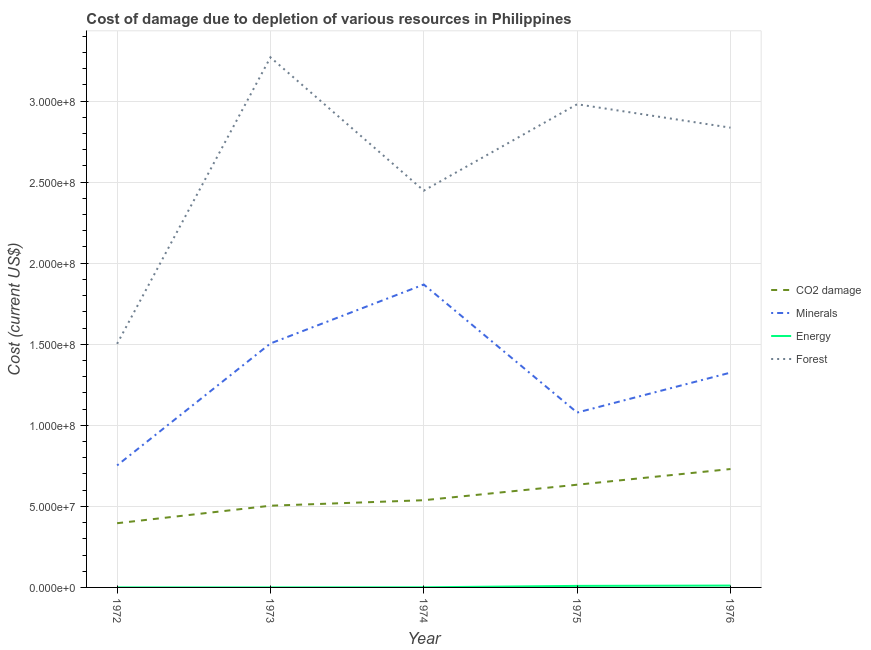How many different coloured lines are there?
Offer a very short reply. 4. What is the cost of damage due to depletion of minerals in 1973?
Your response must be concise. 1.50e+08. Across all years, what is the maximum cost of damage due to depletion of forests?
Give a very brief answer. 3.27e+08. Across all years, what is the minimum cost of damage due to depletion of coal?
Your response must be concise. 3.96e+07. In which year was the cost of damage due to depletion of energy maximum?
Make the answer very short. 1976. What is the total cost of damage due to depletion of minerals in the graph?
Ensure brevity in your answer.  6.53e+08. What is the difference between the cost of damage due to depletion of forests in 1974 and that in 1976?
Your response must be concise. -3.88e+07. What is the difference between the cost of damage due to depletion of energy in 1975 and the cost of damage due to depletion of coal in 1973?
Provide a short and direct response. -4.95e+07. What is the average cost of damage due to depletion of coal per year?
Offer a terse response. 5.60e+07. In the year 1973, what is the difference between the cost of damage due to depletion of energy and cost of damage due to depletion of minerals?
Make the answer very short. -1.50e+08. In how many years, is the cost of damage due to depletion of forests greater than 20000000 US$?
Give a very brief answer. 5. What is the ratio of the cost of damage due to depletion of minerals in 1972 to that in 1974?
Give a very brief answer. 0.4. Is the difference between the cost of damage due to depletion of forests in 1975 and 1976 greater than the difference between the cost of damage due to depletion of coal in 1975 and 1976?
Ensure brevity in your answer.  Yes. What is the difference between the highest and the second highest cost of damage due to depletion of energy?
Offer a terse response. 1.92e+05. What is the difference between the highest and the lowest cost of damage due to depletion of minerals?
Your answer should be very brief. 1.12e+08. Is the cost of damage due to depletion of energy strictly less than the cost of damage due to depletion of coal over the years?
Offer a very short reply. Yes. How many lines are there?
Your answer should be compact. 4. How many years are there in the graph?
Make the answer very short. 5. What is the difference between two consecutive major ticks on the Y-axis?
Offer a very short reply. 5.00e+07. Are the values on the major ticks of Y-axis written in scientific E-notation?
Offer a terse response. Yes. How are the legend labels stacked?
Provide a short and direct response. Vertical. What is the title of the graph?
Provide a short and direct response. Cost of damage due to depletion of various resources in Philippines . What is the label or title of the Y-axis?
Provide a succinct answer. Cost (current US$). What is the Cost (current US$) of CO2 damage in 1972?
Offer a terse response. 3.96e+07. What is the Cost (current US$) in Minerals in 1972?
Make the answer very short. 7.53e+07. What is the Cost (current US$) of Energy in 1972?
Your answer should be compact. 1.34e+04. What is the Cost (current US$) in Forest in 1972?
Provide a short and direct response. 1.50e+08. What is the Cost (current US$) of CO2 damage in 1973?
Your response must be concise. 5.04e+07. What is the Cost (current US$) of Minerals in 1973?
Offer a very short reply. 1.50e+08. What is the Cost (current US$) of Energy in 1973?
Your answer should be very brief. 1.22e+04. What is the Cost (current US$) of Forest in 1973?
Make the answer very short. 3.27e+08. What is the Cost (current US$) of CO2 damage in 1974?
Ensure brevity in your answer.  5.38e+07. What is the Cost (current US$) in Minerals in 1974?
Provide a short and direct response. 1.87e+08. What is the Cost (current US$) of Energy in 1974?
Offer a terse response. 7.59e+04. What is the Cost (current US$) of Forest in 1974?
Provide a short and direct response. 2.45e+08. What is the Cost (current US$) in CO2 damage in 1975?
Provide a short and direct response. 6.34e+07. What is the Cost (current US$) in Minerals in 1975?
Offer a very short reply. 1.08e+08. What is the Cost (current US$) of Energy in 1975?
Make the answer very short. 9.46e+05. What is the Cost (current US$) in Forest in 1975?
Keep it short and to the point. 2.98e+08. What is the Cost (current US$) in CO2 damage in 1976?
Give a very brief answer. 7.30e+07. What is the Cost (current US$) in Minerals in 1976?
Your answer should be very brief. 1.33e+08. What is the Cost (current US$) of Energy in 1976?
Your answer should be compact. 1.14e+06. What is the Cost (current US$) of Forest in 1976?
Make the answer very short. 2.84e+08. Across all years, what is the maximum Cost (current US$) of CO2 damage?
Your answer should be very brief. 7.30e+07. Across all years, what is the maximum Cost (current US$) of Minerals?
Your response must be concise. 1.87e+08. Across all years, what is the maximum Cost (current US$) of Energy?
Your answer should be compact. 1.14e+06. Across all years, what is the maximum Cost (current US$) of Forest?
Keep it short and to the point. 3.27e+08. Across all years, what is the minimum Cost (current US$) in CO2 damage?
Give a very brief answer. 3.96e+07. Across all years, what is the minimum Cost (current US$) of Minerals?
Ensure brevity in your answer.  7.53e+07. Across all years, what is the minimum Cost (current US$) in Energy?
Offer a terse response. 1.22e+04. Across all years, what is the minimum Cost (current US$) in Forest?
Ensure brevity in your answer.  1.50e+08. What is the total Cost (current US$) of CO2 damage in the graph?
Offer a very short reply. 2.80e+08. What is the total Cost (current US$) in Minerals in the graph?
Keep it short and to the point. 6.53e+08. What is the total Cost (current US$) of Energy in the graph?
Provide a short and direct response. 2.19e+06. What is the total Cost (current US$) of Forest in the graph?
Your answer should be very brief. 1.30e+09. What is the difference between the Cost (current US$) of CO2 damage in 1972 and that in 1973?
Make the answer very short. -1.08e+07. What is the difference between the Cost (current US$) in Minerals in 1972 and that in 1973?
Offer a terse response. -7.52e+07. What is the difference between the Cost (current US$) in Energy in 1972 and that in 1973?
Your response must be concise. 1198.15. What is the difference between the Cost (current US$) of Forest in 1972 and that in 1973?
Make the answer very short. -1.77e+08. What is the difference between the Cost (current US$) in CO2 damage in 1972 and that in 1974?
Your response must be concise. -1.42e+07. What is the difference between the Cost (current US$) in Minerals in 1972 and that in 1974?
Keep it short and to the point. -1.12e+08. What is the difference between the Cost (current US$) of Energy in 1972 and that in 1974?
Your answer should be very brief. -6.26e+04. What is the difference between the Cost (current US$) in Forest in 1972 and that in 1974?
Your response must be concise. -9.45e+07. What is the difference between the Cost (current US$) of CO2 damage in 1972 and that in 1975?
Make the answer very short. -2.37e+07. What is the difference between the Cost (current US$) in Minerals in 1972 and that in 1975?
Give a very brief answer. -3.26e+07. What is the difference between the Cost (current US$) in Energy in 1972 and that in 1975?
Provide a succinct answer. -9.33e+05. What is the difference between the Cost (current US$) in Forest in 1972 and that in 1975?
Ensure brevity in your answer.  -1.48e+08. What is the difference between the Cost (current US$) of CO2 damage in 1972 and that in 1976?
Ensure brevity in your answer.  -3.34e+07. What is the difference between the Cost (current US$) of Minerals in 1972 and that in 1976?
Your response must be concise. -5.72e+07. What is the difference between the Cost (current US$) of Energy in 1972 and that in 1976?
Give a very brief answer. -1.13e+06. What is the difference between the Cost (current US$) in Forest in 1972 and that in 1976?
Keep it short and to the point. -1.33e+08. What is the difference between the Cost (current US$) of CO2 damage in 1973 and that in 1974?
Make the answer very short. -3.39e+06. What is the difference between the Cost (current US$) in Minerals in 1973 and that in 1974?
Make the answer very short. -3.64e+07. What is the difference between the Cost (current US$) in Energy in 1973 and that in 1974?
Offer a terse response. -6.38e+04. What is the difference between the Cost (current US$) in Forest in 1973 and that in 1974?
Make the answer very short. 8.22e+07. What is the difference between the Cost (current US$) of CO2 damage in 1973 and that in 1975?
Offer a very short reply. -1.29e+07. What is the difference between the Cost (current US$) in Minerals in 1973 and that in 1975?
Keep it short and to the point. 4.26e+07. What is the difference between the Cost (current US$) of Energy in 1973 and that in 1975?
Your response must be concise. -9.34e+05. What is the difference between the Cost (current US$) of Forest in 1973 and that in 1975?
Make the answer very short. 2.89e+07. What is the difference between the Cost (current US$) of CO2 damage in 1973 and that in 1976?
Give a very brief answer. -2.26e+07. What is the difference between the Cost (current US$) of Minerals in 1973 and that in 1976?
Provide a short and direct response. 1.80e+07. What is the difference between the Cost (current US$) of Energy in 1973 and that in 1976?
Ensure brevity in your answer.  -1.13e+06. What is the difference between the Cost (current US$) of Forest in 1973 and that in 1976?
Give a very brief answer. 4.34e+07. What is the difference between the Cost (current US$) in CO2 damage in 1974 and that in 1975?
Provide a short and direct response. -9.56e+06. What is the difference between the Cost (current US$) in Minerals in 1974 and that in 1975?
Your answer should be very brief. 7.90e+07. What is the difference between the Cost (current US$) in Energy in 1974 and that in 1975?
Offer a terse response. -8.70e+05. What is the difference between the Cost (current US$) in Forest in 1974 and that in 1975?
Your response must be concise. -5.33e+07. What is the difference between the Cost (current US$) of CO2 damage in 1974 and that in 1976?
Your response must be concise. -1.92e+07. What is the difference between the Cost (current US$) in Minerals in 1974 and that in 1976?
Offer a terse response. 5.43e+07. What is the difference between the Cost (current US$) in Energy in 1974 and that in 1976?
Provide a short and direct response. -1.06e+06. What is the difference between the Cost (current US$) of Forest in 1974 and that in 1976?
Provide a short and direct response. -3.88e+07. What is the difference between the Cost (current US$) in CO2 damage in 1975 and that in 1976?
Ensure brevity in your answer.  -9.68e+06. What is the difference between the Cost (current US$) in Minerals in 1975 and that in 1976?
Provide a succinct answer. -2.46e+07. What is the difference between the Cost (current US$) in Energy in 1975 and that in 1976?
Provide a succinct answer. -1.92e+05. What is the difference between the Cost (current US$) of Forest in 1975 and that in 1976?
Your answer should be very brief. 1.45e+07. What is the difference between the Cost (current US$) in CO2 damage in 1972 and the Cost (current US$) in Minerals in 1973?
Make the answer very short. -1.11e+08. What is the difference between the Cost (current US$) in CO2 damage in 1972 and the Cost (current US$) in Energy in 1973?
Offer a terse response. 3.96e+07. What is the difference between the Cost (current US$) in CO2 damage in 1972 and the Cost (current US$) in Forest in 1973?
Provide a succinct answer. -2.87e+08. What is the difference between the Cost (current US$) in Minerals in 1972 and the Cost (current US$) in Energy in 1973?
Ensure brevity in your answer.  7.52e+07. What is the difference between the Cost (current US$) of Minerals in 1972 and the Cost (current US$) of Forest in 1973?
Your answer should be compact. -2.52e+08. What is the difference between the Cost (current US$) of Energy in 1972 and the Cost (current US$) of Forest in 1973?
Your answer should be compact. -3.27e+08. What is the difference between the Cost (current US$) of CO2 damage in 1972 and the Cost (current US$) of Minerals in 1974?
Offer a terse response. -1.47e+08. What is the difference between the Cost (current US$) of CO2 damage in 1972 and the Cost (current US$) of Energy in 1974?
Keep it short and to the point. 3.95e+07. What is the difference between the Cost (current US$) in CO2 damage in 1972 and the Cost (current US$) in Forest in 1974?
Keep it short and to the point. -2.05e+08. What is the difference between the Cost (current US$) in Minerals in 1972 and the Cost (current US$) in Energy in 1974?
Give a very brief answer. 7.52e+07. What is the difference between the Cost (current US$) of Minerals in 1972 and the Cost (current US$) of Forest in 1974?
Make the answer very short. -1.69e+08. What is the difference between the Cost (current US$) in Energy in 1972 and the Cost (current US$) in Forest in 1974?
Your response must be concise. -2.45e+08. What is the difference between the Cost (current US$) of CO2 damage in 1972 and the Cost (current US$) of Minerals in 1975?
Offer a terse response. -6.83e+07. What is the difference between the Cost (current US$) of CO2 damage in 1972 and the Cost (current US$) of Energy in 1975?
Your response must be concise. 3.87e+07. What is the difference between the Cost (current US$) in CO2 damage in 1972 and the Cost (current US$) in Forest in 1975?
Keep it short and to the point. -2.58e+08. What is the difference between the Cost (current US$) of Minerals in 1972 and the Cost (current US$) of Energy in 1975?
Ensure brevity in your answer.  7.43e+07. What is the difference between the Cost (current US$) of Minerals in 1972 and the Cost (current US$) of Forest in 1975?
Give a very brief answer. -2.23e+08. What is the difference between the Cost (current US$) of Energy in 1972 and the Cost (current US$) of Forest in 1975?
Give a very brief answer. -2.98e+08. What is the difference between the Cost (current US$) in CO2 damage in 1972 and the Cost (current US$) in Minerals in 1976?
Offer a terse response. -9.29e+07. What is the difference between the Cost (current US$) of CO2 damage in 1972 and the Cost (current US$) of Energy in 1976?
Keep it short and to the point. 3.85e+07. What is the difference between the Cost (current US$) of CO2 damage in 1972 and the Cost (current US$) of Forest in 1976?
Provide a short and direct response. -2.44e+08. What is the difference between the Cost (current US$) of Minerals in 1972 and the Cost (current US$) of Energy in 1976?
Your answer should be very brief. 7.41e+07. What is the difference between the Cost (current US$) in Minerals in 1972 and the Cost (current US$) in Forest in 1976?
Give a very brief answer. -2.08e+08. What is the difference between the Cost (current US$) in Energy in 1972 and the Cost (current US$) in Forest in 1976?
Your response must be concise. -2.84e+08. What is the difference between the Cost (current US$) of CO2 damage in 1973 and the Cost (current US$) of Minerals in 1974?
Give a very brief answer. -1.36e+08. What is the difference between the Cost (current US$) in CO2 damage in 1973 and the Cost (current US$) in Energy in 1974?
Provide a succinct answer. 5.03e+07. What is the difference between the Cost (current US$) in CO2 damage in 1973 and the Cost (current US$) in Forest in 1974?
Your answer should be compact. -1.94e+08. What is the difference between the Cost (current US$) of Minerals in 1973 and the Cost (current US$) of Energy in 1974?
Make the answer very short. 1.50e+08. What is the difference between the Cost (current US$) in Minerals in 1973 and the Cost (current US$) in Forest in 1974?
Give a very brief answer. -9.43e+07. What is the difference between the Cost (current US$) in Energy in 1973 and the Cost (current US$) in Forest in 1974?
Offer a terse response. -2.45e+08. What is the difference between the Cost (current US$) of CO2 damage in 1973 and the Cost (current US$) of Minerals in 1975?
Your answer should be very brief. -5.75e+07. What is the difference between the Cost (current US$) in CO2 damage in 1973 and the Cost (current US$) in Energy in 1975?
Give a very brief answer. 4.95e+07. What is the difference between the Cost (current US$) in CO2 damage in 1973 and the Cost (current US$) in Forest in 1975?
Make the answer very short. -2.48e+08. What is the difference between the Cost (current US$) in Minerals in 1973 and the Cost (current US$) in Energy in 1975?
Make the answer very short. 1.50e+08. What is the difference between the Cost (current US$) of Minerals in 1973 and the Cost (current US$) of Forest in 1975?
Your answer should be very brief. -1.48e+08. What is the difference between the Cost (current US$) in Energy in 1973 and the Cost (current US$) in Forest in 1975?
Your response must be concise. -2.98e+08. What is the difference between the Cost (current US$) in CO2 damage in 1973 and the Cost (current US$) in Minerals in 1976?
Keep it short and to the point. -8.21e+07. What is the difference between the Cost (current US$) in CO2 damage in 1973 and the Cost (current US$) in Energy in 1976?
Your answer should be compact. 4.93e+07. What is the difference between the Cost (current US$) in CO2 damage in 1973 and the Cost (current US$) in Forest in 1976?
Offer a very short reply. -2.33e+08. What is the difference between the Cost (current US$) in Minerals in 1973 and the Cost (current US$) in Energy in 1976?
Provide a succinct answer. 1.49e+08. What is the difference between the Cost (current US$) of Minerals in 1973 and the Cost (current US$) of Forest in 1976?
Your response must be concise. -1.33e+08. What is the difference between the Cost (current US$) of Energy in 1973 and the Cost (current US$) of Forest in 1976?
Give a very brief answer. -2.84e+08. What is the difference between the Cost (current US$) in CO2 damage in 1974 and the Cost (current US$) in Minerals in 1975?
Ensure brevity in your answer.  -5.41e+07. What is the difference between the Cost (current US$) in CO2 damage in 1974 and the Cost (current US$) in Energy in 1975?
Offer a very short reply. 5.28e+07. What is the difference between the Cost (current US$) in CO2 damage in 1974 and the Cost (current US$) in Forest in 1975?
Give a very brief answer. -2.44e+08. What is the difference between the Cost (current US$) in Minerals in 1974 and the Cost (current US$) in Energy in 1975?
Provide a succinct answer. 1.86e+08. What is the difference between the Cost (current US$) in Minerals in 1974 and the Cost (current US$) in Forest in 1975?
Your response must be concise. -1.11e+08. What is the difference between the Cost (current US$) of Energy in 1974 and the Cost (current US$) of Forest in 1975?
Your response must be concise. -2.98e+08. What is the difference between the Cost (current US$) of CO2 damage in 1974 and the Cost (current US$) of Minerals in 1976?
Your answer should be compact. -7.87e+07. What is the difference between the Cost (current US$) of CO2 damage in 1974 and the Cost (current US$) of Energy in 1976?
Keep it short and to the point. 5.27e+07. What is the difference between the Cost (current US$) of CO2 damage in 1974 and the Cost (current US$) of Forest in 1976?
Provide a short and direct response. -2.30e+08. What is the difference between the Cost (current US$) in Minerals in 1974 and the Cost (current US$) in Energy in 1976?
Ensure brevity in your answer.  1.86e+08. What is the difference between the Cost (current US$) of Minerals in 1974 and the Cost (current US$) of Forest in 1976?
Your response must be concise. -9.68e+07. What is the difference between the Cost (current US$) of Energy in 1974 and the Cost (current US$) of Forest in 1976?
Provide a succinct answer. -2.84e+08. What is the difference between the Cost (current US$) of CO2 damage in 1975 and the Cost (current US$) of Minerals in 1976?
Your answer should be very brief. -6.92e+07. What is the difference between the Cost (current US$) in CO2 damage in 1975 and the Cost (current US$) in Energy in 1976?
Make the answer very short. 6.22e+07. What is the difference between the Cost (current US$) of CO2 damage in 1975 and the Cost (current US$) of Forest in 1976?
Provide a short and direct response. -2.20e+08. What is the difference between the Cost (current US$) of Minerals in 1975 and the Cost (current US$) of Energy in 1976?
Make the answer very short. 1.07e+08. What is the difference between the Cost (current US$) of Minerals in 1975 and the Cost (current US$) of Forest in 1976?
Your answer should be compact. -1.76e+08. What is the difference between the Cost (current US$) in Energy in 1975 and the Cost (current US$) in Forest in 1976?
Provide a succinct answer. -2.83e+08. What is the average Cost (current US$) in CO2 damage per year?
Provide a short and direct response. 5.60e+07. What is the average Cost (current US$) of Minerals per year?
Offer a very short reply. 1.31e+08. What is the average Cost (current US$) in Energy per year?
Keep it short and to the point. 4.37e+05. What is the average Cost (current US$) of Forest per year?
Offer a very short reply. 2.61e+08. In the year 1972, what is the difference between the Cost (current US$) in CO2 damage and Cost (current US$) in Minerals?
Provide a succinct answer. -3.57e+07. In the year 1972, what is the difference between the Cost (current US$) in CO2 damage and Cost (current US$) in Energy?
Ensure brevity in your answer.  3.96e+07. In the year 1972, what is the difference between the Cost (current US$) in CO2 damage and Cost (current US$) in Forest?
Your response must be concise. -1.11e+08. In the year 1972, what is the difference between the Cost (current US$) in Minerals and Cost (current US$) in Energy?
Provide a short and direct response. 7.52e+07. In the year 1972, what is the difference between the Cost (current US$) of Minerals and Cost (current US$) of Forest?
Give a very brief answer. -7.50e+07. In the year 1972, what is the difference between the Cost (current US$) in Energy and Cost (current US$) in Forest?
Ensure brevity in your answer.  -1.50e+08. In the year 1973, what is the difference between the Cost (current US$) of CO2 damage and Cost (current US$) of Minerals?
Make the answer very short. -1.00e+08. In the year 1973, what is the difference between the Cost (current US$) of CO2 damage and Cost (current US$) of Energy?
Your answer should be compact. 5.04e+07. In the year 1973, what is the difference between the Cost (current US$) of CO2 damage and Cost (current US$) of Forest?
Offer a very short reply. -2.77e+08. In the year 1973, what is the difference between the Cost (current US$) in Minerals and Cost (current US$) in Energy?
Offer a very short reply. 1.50e+08. In the year 1973, what is the difference between the Cost (current US$) of Minerals and Cost (current US$) of Forest?
Offer a very short reply. -1.77e+08. In the year 1973, what is the difference between the Cost (current US$) of Energy and Cost (current US$) of Forest?
Make the answer very short. -3.27e+08. In the year 1974, what is the difference between the Cost (current US$) of CO2 damage and Cost (current US$) of Minerals?
Provide a short and direct response. -1.33e+08. In the year 1974, what is the difference between the Cost (current US$) in CO2 damage and Cost (current US$) in Energy?
Offer a very short reply. 5.37e+07. In the year 1974, what is the difference between the Cost (current US$) of CO2 damage and Cost (current US$) of Forest?
Keep it short and to the point. -1.91e+08. In the year 1974, what is the difference between the Cost (current US$) of Minerals and Cost (current US$) of Energy?
Offer a very short reply. 1.87e+08. In the year 1974, what is the difference between the Cost (current US$) of Minerals and Cost (current US$) of Forest?
Make the answer very short. -5.79e+07. In the year 1974, what is the difference between the Cost (current US$) in Energy and Cost (current US$) in Forest?
Make the answer very short. -2.45e+08. In the year 1975, what is the difference between the Cost (current US$) of CO2 damage and Cost (current US$) of Minerals?
Your response must be concise. -4.45e+07. In the year 1975, what is the difference between the Cost (current US$) in CO2 damage and Cost (current US$) in Energy?
Your response must be concise. 6.24e+07. In the year 1975, what is the difference between the Cost (current US$) in CO2 damage and Cost (current US$) in Forest?
Provide a succinct answer. -2.35e+08. In the year 1975, what is the difference between the Cost (current US$) in Minerals and Cost (current US$) in Energy?
Your answer should be compact. 1.07e+08. In the year 1975, what is the difference between the Cost (current US$) in Minerals and Cost (current US$) in Forest?
Your answer should be very brief. -1.90e+08. In the year 1975, what is the difference between the Cost (current US$) of Energy and Cost (current US$) of Forest?
Ensure brevity in your answer.  -2.97e+08. In the year 1976, what is the difference between the Cost (current US$) of CO2 damage and Cost (current US$) of Minerals?
Offer a terse response. -5.95e+07. In the year 1976, what is the difference between the Cost (current US$) in CO2 damage and Cost (current US$) in Energy?
Give a very brief answer. 7.19e+07. In the year 1976, what is the difference between the Cost (current US$) of CO2 damage and Cost (current US$) of Forest?
Your response must be concise. -2.11e+08. In the year 1976, what is the difference between the Cost (current US$) of Minerals and Cost (current US$) of Energy?
Your answer should be compact. 1.31e+08. In the year 1976, what is the difference between the Cost (current US$) of Minerals and Cost (current US$) of Forest?
Ensure brevity in your answer.  -1.51e+08. In the year 1976, what is the difference between the Cost (current US$) of Energy and Cost (current US$) of Forest?
Provide a short and direct response. -2.82e+08. What is the ratio of the Cost (current US$) in CO2 damage in 1972 to that in 1973?
Make the answer very short. 0.79. What is the ratio of the Cost (current US$) of Minerals in 1972 to that in 1973?
Offer a very short reply. 0.5. What is the ratio of the Cost (current US$) in Energy in 1972 to that in 1973?
Ensure brevity in your answer.  1.1. What is the ratio of the Cost (current US$) of Forest in 1972 to that in 1973?
Make the answer very short. 0.46. What is the ratio of the Cost (current US$) in CO2 damage in 1972 to that in 1974?
Keep it short and to the point. 0.74. What is the ratio of the Cost (current US$) of Minerals in 1972 to that in 1974?
Make the answer very short. 0.4. What is the ratio of the Cost (current US$) in Energy in 1972 to that in 1974?
Give a very brief answer. 0.18. What is the ratio of the Cost (current US$) in Forest in 1972 to that in 1974?
Make the answer very short. 0.61. What is the ratio of the Cost (current US$) of CO2 damage in 1972 to that in 1975?
Ensure brevity in your answer.  0.63. What is the ratio of the Cost (current US$) of Minerals in 1972 to that in 1975?
Offer a very short reply. 0.7. What is the ratio of the Cost (current US$) in Energy in 1972 to that in 1975?
Your answer should be compact. 0.01. What is the ratio of the Cost (current US$) in Forest in 1972 to that in 1975?
Your answer should be compact. 0.5. What is the ratio of the Cost (current US$) of CO2 damage in 1972 to that in 1976?
Ensure brevity in your answer.  0.54. What is the ratio of the Cost (current US$) in Minerals in 1972 to that in 1976?
Your answer should be very brief. 0.57. What is the ratio of the Cost (current US$) in Energy in 1972 to that in 1976?
Ensure brevity in your answer.  0.01. What is the ratio of the Cost (current US$) of Forest in 1972 to that in 1976?
Provide a succinct answer. 0.53. What is the ratio of the Cost (current US$) of CO2 damage in 1973 to that in 1974?
Provide a succinct answer. 0.94. What is the ratio of the Cost (current US$) in Minerals in 1973 to that in 1974?
Offer a terse response. 0.81. What is the ratio of the Cost (current US$) in Energy in 1973 to that in 1974?
Provide a short and direct response. 0.16. What is the ratio of the Cost (current US$) of Forest in 1973 to that in 1974?
Your answer should be very brief. 1.34. What is the ratio of the Cost (current US$) of CO2 damage in 1973 to that in 1975?
Ensure brevity in your answer.  0.8. What is the ratio of the Cost (current US$) of Minerals in 1973 to that in 1975?
Provide a short and direct response. 1.4. What is the ratio of the Cost (current US$) of Energy in 1973 to that in 1975?
Your answer should be compact. 0.01. What is the ratio of the Cost (current US$) in Forest in 1973 to that in 1975?
Keep it short and to the point. 1.1. What is the ratio of the Cost (current US$) of CO2 damage in 1973 to that in 1976?
Offer a very short reply. 0.69. What is the ratio of the Cost (current US$) in Minerals in 1973 to that in 1976?
Offer a terse response. 1.14. What is the ratio of the Cost (current US$) of Energy in 1973 to that in 1976?
Keep it short and to the point. 0.01. What is the ratio of the Cost (current US$) of Forest in 1973 to that in 1976?
Your response must be concise. 1.15. What is the ratio of the Cost (current US$) of CO2 damage in 1974 to that in 1975?
Provide a short and direct response. 0.85. What is the ratio of the Cost (current US$) in Minerals in 1974 to that in 1975?
Make the answer very short. 1.73. What is the ratio of the Cost (current US$) of Energy in 1974 to that in 1975?
Offer a very short reply. 0.08. What is the ratio of the Cost (current US$) of Forest in 1974 to that in 1975?
Your answer should be compact. 0.82. What is the ratio of the Cost (current US$) of CO2 damage in 1974 to that in 1976?
Your answer should be compact. 0.74. What is the ratio of the Cost (current US$) in Minerals in 1974 to that in 1976?
Offer a very short reply. 1.41. What is the ratio of the Cost (current US$) in Energy in 1974 to that in 1976?
Keep it short and to the point. 0.07. What is the ratio of the Cost (current US$) in Forest in 1974 to that in 1976?
Ensure brevity in your answer.  0.86. What is the ratio of the Cost (current US$) of CO2 damage in 1975 to that in 1976?
Give a very brief answer. 0.87. What is the ratio of the Cost (current US$) in Minerals in 1975 to that in 1976?
Your answer should be very brief. 0.81. What is the ratio of the Cost (current US$) in Energy in 1975 to that in 1976?
Provide a succinct answer. 0.83. What is the ratio of the Cost (current US$) in Forest in 1975 to that in 1976?
Provide a short and direct response. 1.05. What is the difference between the highest and the second highest Cost (current US$) of CO2 damage?
Offer a very short reply. 9.68e+06. What is the difference between the highest and the second highest Cost (current US$) of Minerals?
Your answer should be very brief. 3.64e+07. What is the difference between the highest and the second highest Cost (current US$) in Energy?
Give a very brief answer. 1.92e+05. What is the difference between the highest and the second highest Cost (current US$) of Forest?
Give a very brief answer. 2.89e+07. What is the difference between the highest and the lowest Cost (current US$) in CO2 damage?
Ensure brevity in your answer.  3.34e+07. What is the difference between the highest and the lowest Cost (current US$) of Minerals?
Your answer should be very brief. 1.12e+08. What is the difference between the highest and the lowest Cost (current US$) of Energy?
Ensure brevity in your answer.  1.13e+06. What is the difference between the highest and the lowest Cost (current US$) of Forest?
Ensure brevity in your answer.  1.77e+08. 